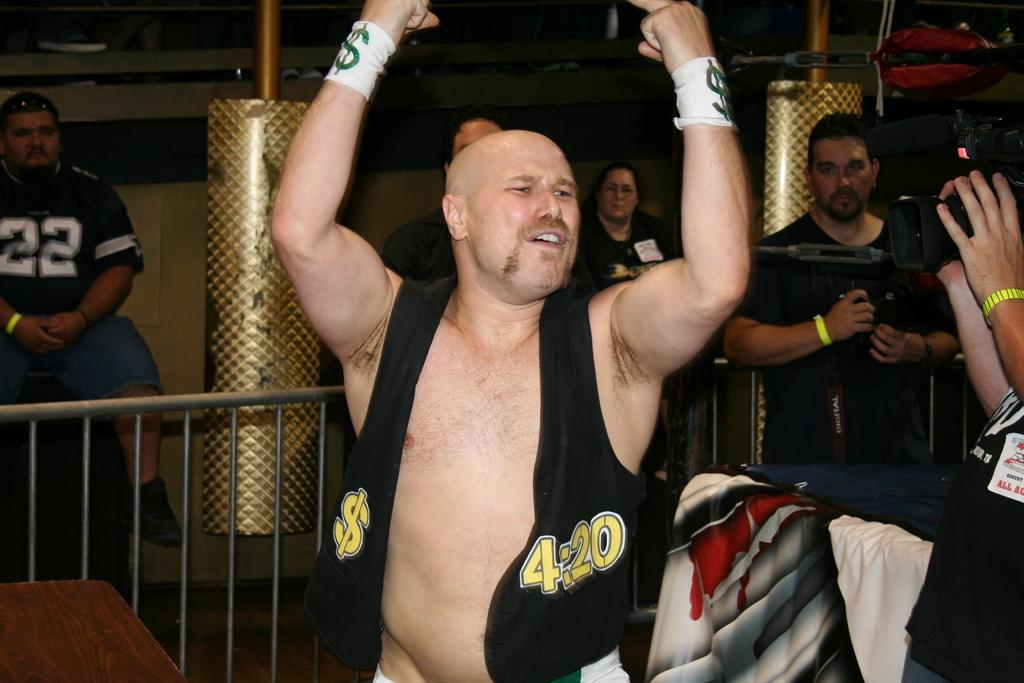Who is the main subject in the foreground of the image? There is a man in the foreground of the image. Can you describe the people behind the man? There are other people behind the man. What separates the man from the people behind him? There is a metal fencing between the people. What type of sink can be seen in the image? There is no sink present in the image. What direction are the trucks moving in the image? There are no trucks present in the image. 